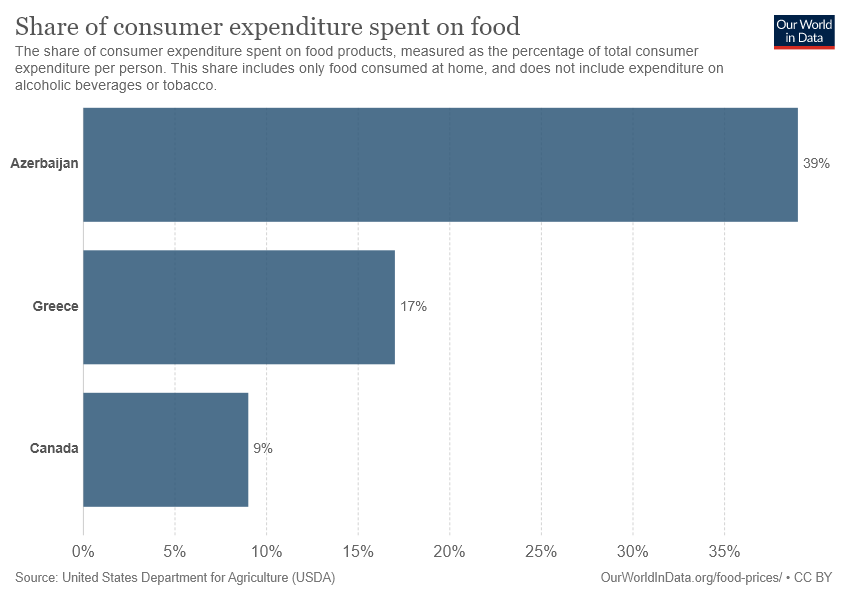Mention a couple of crucial points in this snapshot. The median value is the middle value of a set of data when it is ordered from lowest to highest. The highest value is the highest value in the set of data. The difference between the highest value and the median value is 0.22. According to data, in Greece, food accounts for 0.17% of consumer expenditure. 